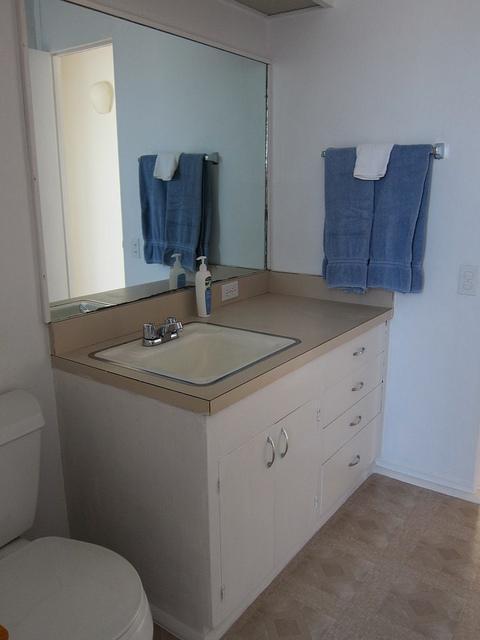How many washcloths are pictured?
Give a very brief answer. 1. How many sinks are there?
Give a very brief answer. 1. How many sinks?
Give a very brief answer. 1. 